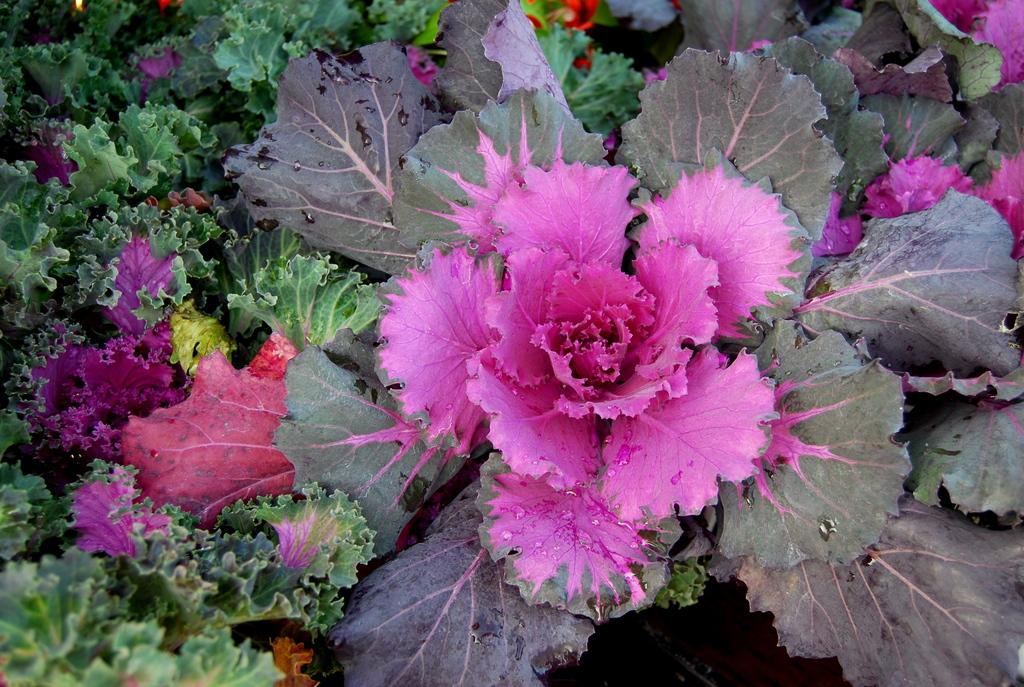What type of natural elements can be seen in the image? There are colorful leaves in the image. What season might the image be depicting? The presence of colorful leaves suggests that the image might be depicting autumn. What colors can be observed in the leaves? The leaves in the image are colorful, featuring shades such as red, orange, and yellow. What type of chain is visible on the shirt in the image? There is no shirt or chain present in the image; it only features colorful leaves. 